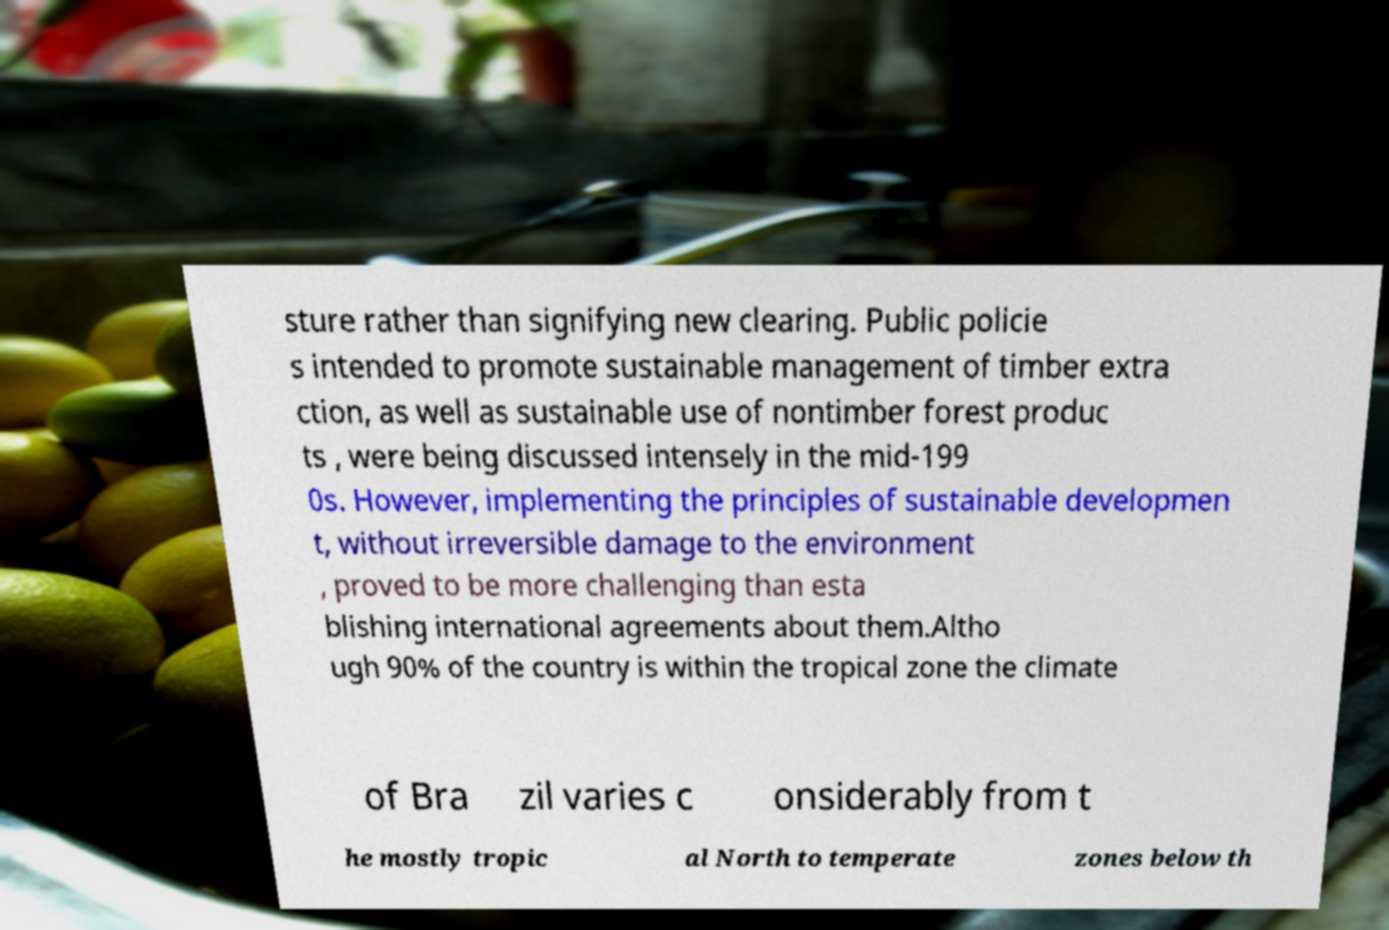I need the written content from this picture converted into text. Can you do that? sture rather than signifying new clearing. Public policie s intended to promote sustainable management of timber extra ction, as well as sustainable use of nontimber forest produc ts , were being discussed intensely in the mid-199 0s. However, implementing the principles of sustainable developmen t, without irreversible damage to the environment , proved to be more challenging than esta blishing international agreements about them.Altho ugh 90% of the country is within the tropical zone the climate of Bra zil varies c onsiderably from t he mostly tropic al North to temperate zones below th 